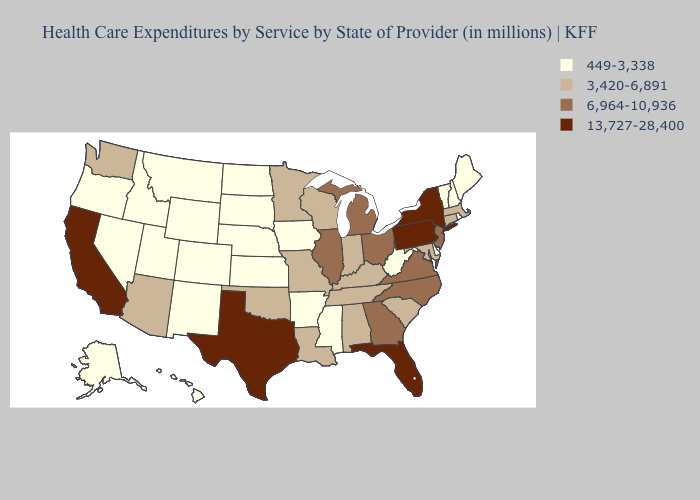Does New York have the highest value in the USA?
Keep it brief. Yes. Which states hav the highest value in the MidWest?
Give a very brief answer. Illinois, Michigan, Ohio. Among the states that border Louisiana , does Mississippi have the highest value?
Quick response, please. No. What is the value of Indiana?
Write a very short answer. 3,420-6,891. Does New Mexico have the same value as Alaska?
Keep it brief. Yes. What is the lowest value in the South?
Give a very brief answer. 449-3,338. Does Florida have the highest value in the USA?
Concise answer only. Yes. Name the states that have a value in the range 449-3,338?
Short answer required. Alaska, Arkansas, Colorado, Delaware, Hawaii, Idaho, Iowa, Kansas, Maine, Mississippi, Montana, Nebraska, Nevada, New Hampshire, New Mexico, North Dakota, Oregon, Rhode Island, South Dakota, Utah, Vermont, West Virginia, Wyoming. What is the value of Iowa?
Keep it brief. 449-3,338. What is the highest value in the Northeast ?
Keep it brief. 13,727-28,400. Does Texas have the highest value in the USA?
Quick response, please. Yes. What is the value of West Virginia?
Give a very brief answer. 449-3,338. Does Hawaii have the lowest value in the USA?
Keep it brief. Yes. Is the legend a continuous bar?
Write a very short answer. No. What is the value of North Carolina?
Give a very brief answer. 6,964-10,936. 